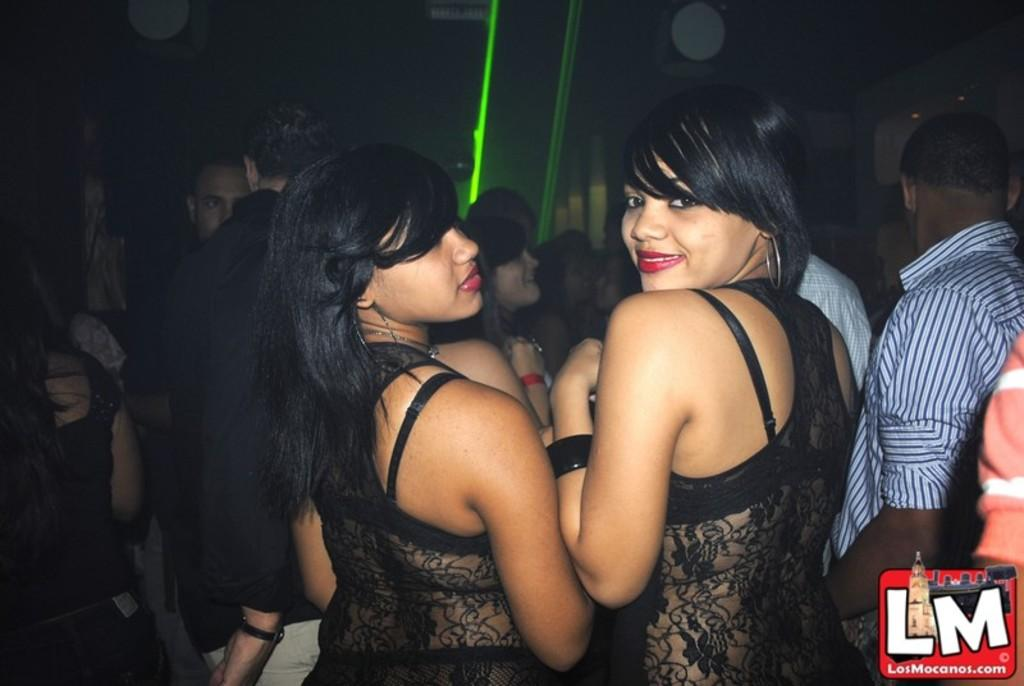How many women are in the image? There are two women in the image. What are the women wearing? The women are wearing black dresses. Can you describe the setting of the image? The image appears to be taken in a pub. What is the general atmosphere in the image? The presence of many people in the background suggests a crowded or lively atmosphere. What decision did the women make together in the image? There is no indication in the image of a decision being made by the women. What rule is being enforced by the crowd in the image? There is no rule being enforced by the crowd in the image; it is simply a gathering of people in a pub. 